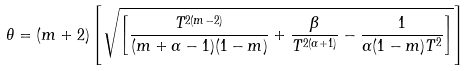Convert formula to latex. <formula><loc_0><loc_0><loc_500><loc_500>\theta = ( m + 2 ) \left [ \sqrt { \left [ \frac { T ^ { 2 ( m - 2 ) } } { ( m + \alpha - 1 ) ( 1 - m ) } + \frac { \beta } { T ^ { 2 ( \alpha + 1 ) } } - \frac { 1 } { \alpha ( 1 - m ) T ^ { 2 } } \right ] } \right ]</formula> 